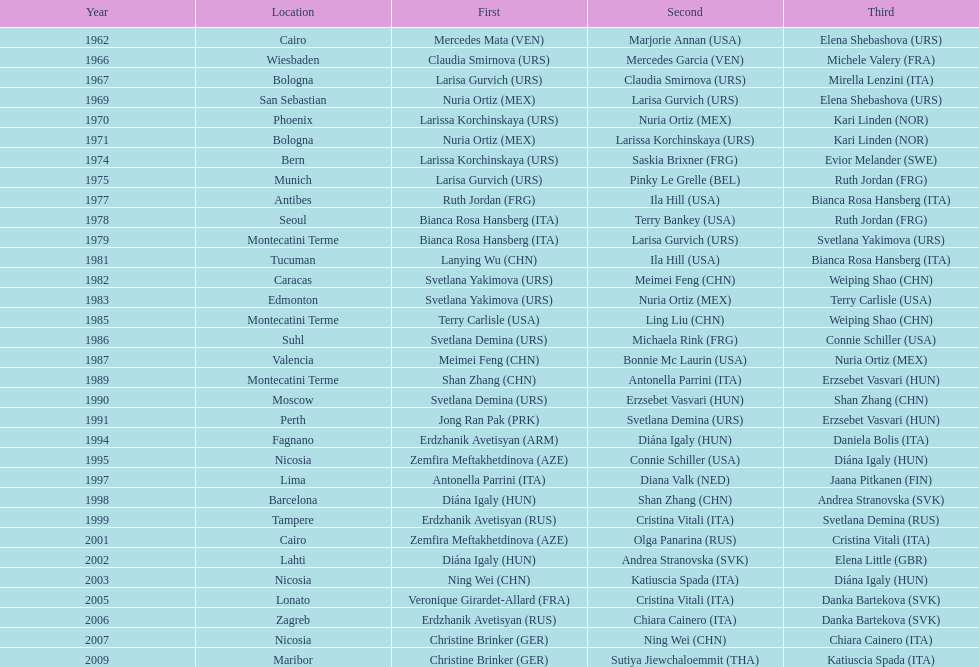How many gold did u.s.a win 1. 